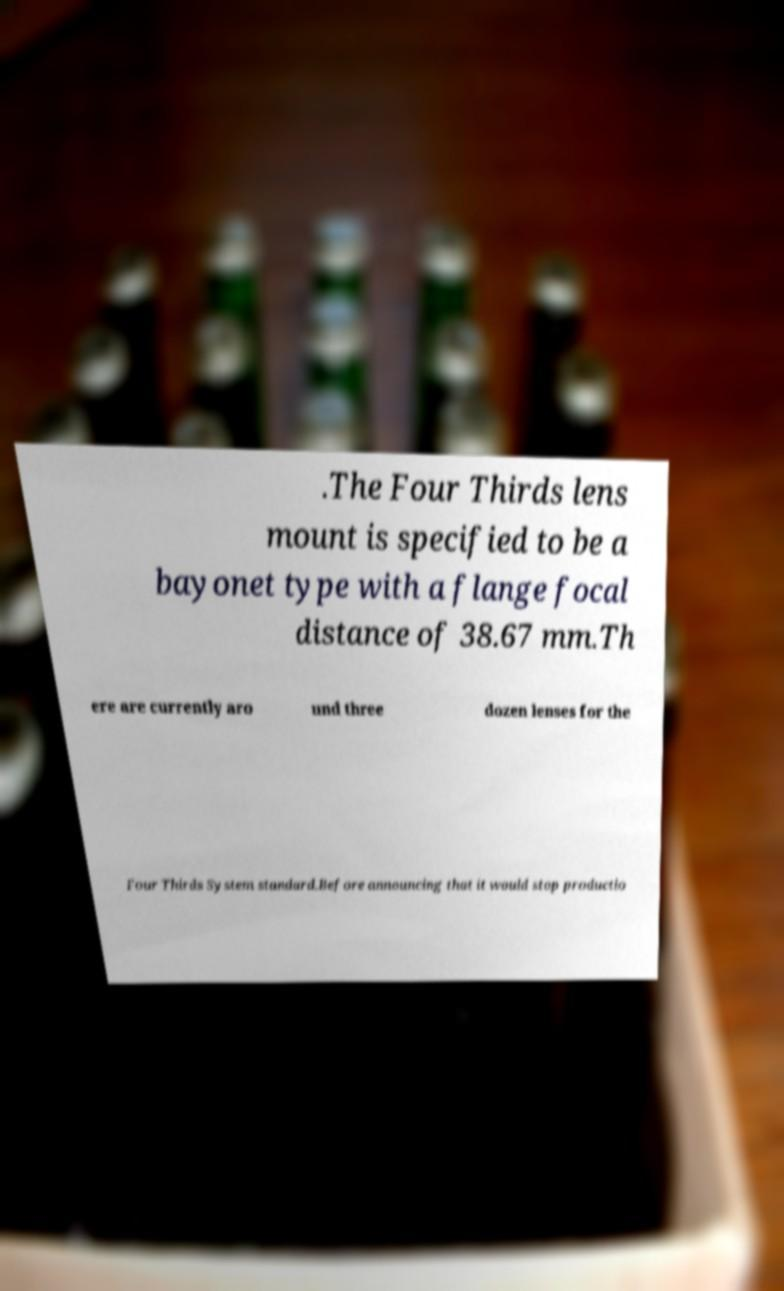Please read and relay the text visible in this image. What does it say? .The Four Thirds lens mount is specified to be a bayonet type with a flange focal distance of 38.67 mm.Th ere are currently aro und three dozen lenses for the Four Thirds System standard.Before announcing that it would stop productio 